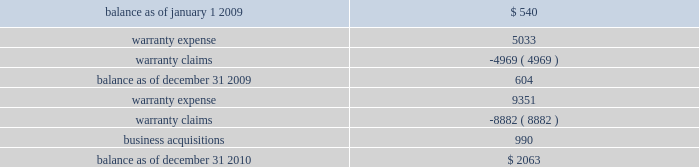On either a straight-line or accelerated basis .
Amortization expense for intangibles was approximately $ 4.2 million , $ 4.1 million and $ 4.1 million during the years ended december 31 , 2010 , 2009 and 2008 , respectively .
Estimated annual amortization expense of the december 31 , 2010 balance for the years ended december 31 , 2011 through 2015 is approximately $ 4.8 million .
Impairment of long-lived assets long-lived assets are reviewed for possible impairment whenever events or circumstances indicate that the carrying amount of such assets may not be recoverable .
If such review indicates that the carrying amount of long- lived assets is not recoverable , the carrying amount of such assets is reduced to fair value .
During the year ended december 31 , 2010 , we recognized impairment charges on certain long-lived assets during the normal course of business of $ 1.3 million .
There were no adjustments to the carrying value of long-lived assets of continuing operations during the years ended december 31 , 2009 or 2008 .
Fair value of financial instruments our debt is reflected on the balance sheet at cost .
Based on market conditions as of december 31 , 2010 , the fair value of our term loans ( see note 5 , 201clong-term obligations 201d ) reasonably approximated the carrying value of $ 590 million .
At december 31 , 2009 , the fair value of our term loans at $ 570 million was below the carrying value of $ 596 million because our interest rate margins were below the rate available in the market .
We estimated the fair value of our term loans by calculating the upfront cash payment a market participant would require to assume our obligations .
The upfront cash payment , excluding any issuance costs , is the amount that a market participant would be able to lend at december 31 , 2010 and 2009 to an entity with a credit rating similar to ours and achieve sufficient cash inflows to cover the scheduled cash outflows under our term loans .
The carrying amounts of our cash and equivalents , net trade receivables and accounts payable approximate fair value .
We apply the market and income approaches to value our financial assets and liabilities , which include the cash surrender value of life insurance , deferred compensation liabilities and interest rate swaps .
Required fair value disclosures are included in note 7 , 201cfair value measurements . 201d product warranties some of our salvage mechanical products are sold with a standard six-month warranty against defects .
Additionally , some of our remanufactured engines are sold with a standard three-year warranty against defects .
We record the estimated warranty costs at the time of sale using historical warranty claim information to project future warranty claims activity and related expenses .
The changes in the warranty reserve are as follows ( in thousands ) : .
Self-insurance reserves we self-insure a portion of employee medical benefits under the terms of our employee health insurance program .
We purchase certain stop-loss insurance to limit our liability exposure .
We also self-insure a portion of .
What was the percentage change in warranty reserve between 2009 and 2010? 
Computations: ((2063 - 604) / 604)
Answer: 2.41556. 